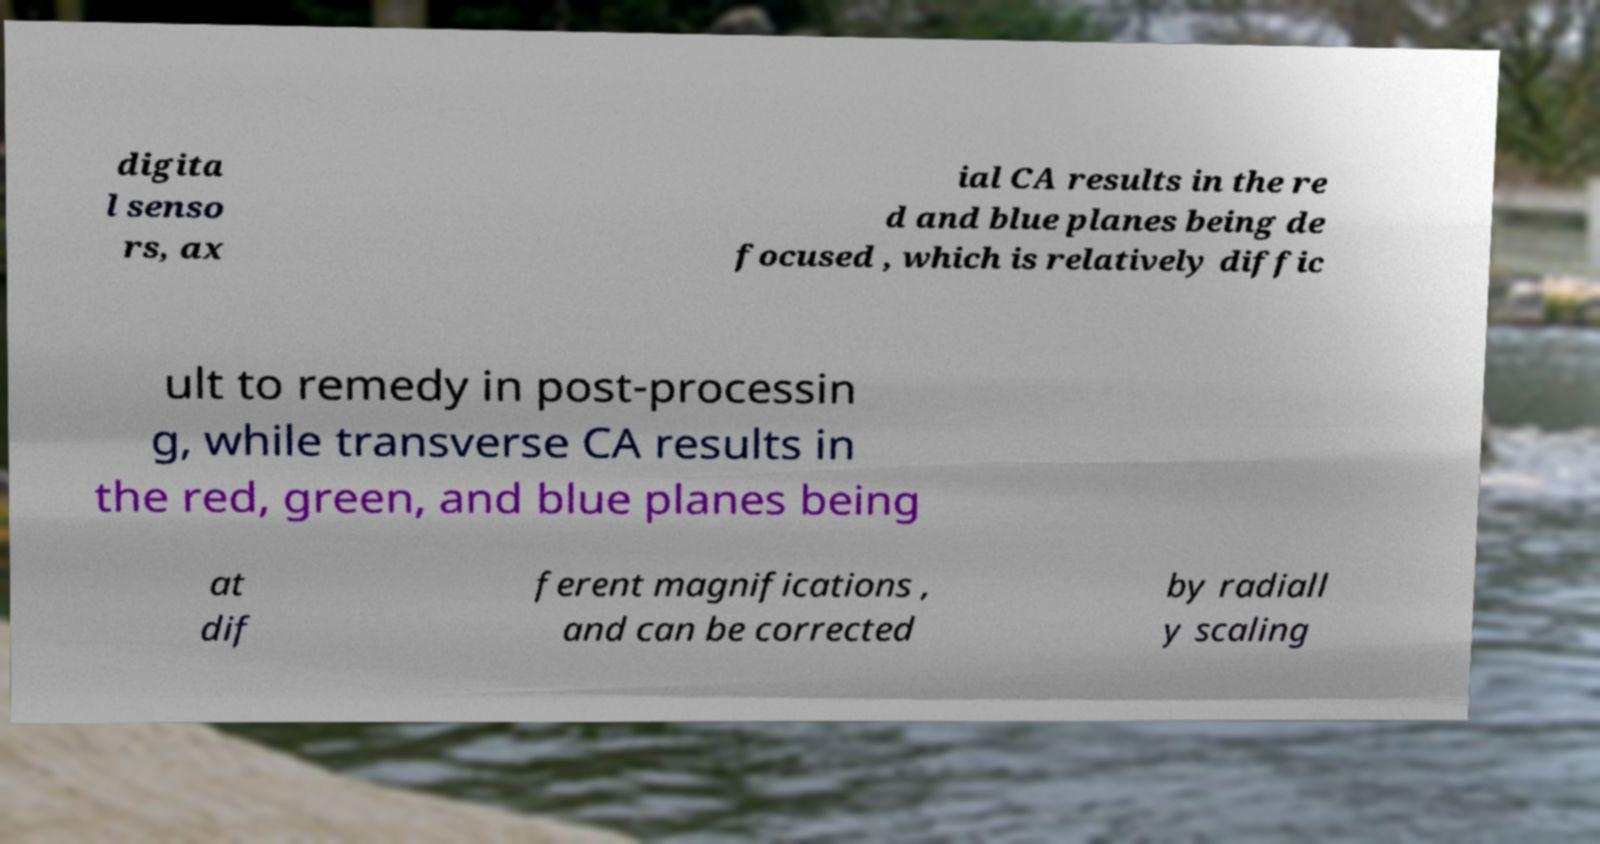Please read and relay the text visible in this image. What does it say? digita l senso rs, ax ial CA results in the re d and blue planes being de focused , which is relatively diffic ult to remedy in post-processin g, while transverse CA results in the red, green, and blue planes being at dif ferent magnifications , and can be corrected by radiall y scaling 